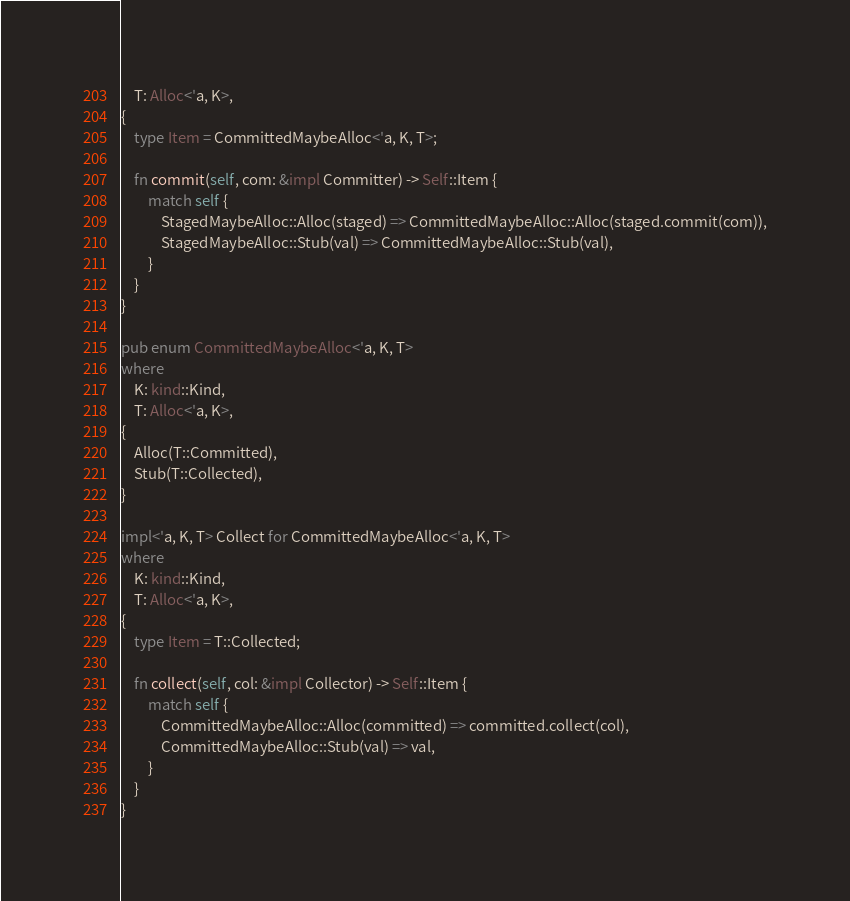<code> <loc_0><loc_0><loc_500><loc_500><_Rust_>    T: Alloc<'a, K>,
{
    type Item = CommittedMaybeAlloc<'a, K, T>;

    fn commit(self, com: &impl Committer) -> Self::Item {
        match self {
            StagedMaybeAlloc::Alloc(staged) => CommittedMaybeAlloc::Alloc(staged.commit(com)),
            StagedMaybeAlloc::Stub(val) => CommittedMaybeAlloc::Stub(val),
        }
    }
}

pub enum CommittedMaybeAlloc<'a, K, T>
where
    K: kind::Kind,
    T: Alloc<'a, K>,
{
    Alloc(T::Committed),
    Stub(T::Collected),
}

impl<'a, K, T> Collect for CommittedMaybeAlloc<'a, K, T>
where
    K: kind::Kind,
    T: Alloc<'a, K>,
{
    type Item = T::Collected;

    fn collect(self, col: &impl Collector) -> Self::Item {
        match self {
            CommittedMaybeAlloc::Alloc(committed) => committed.collect(col),
            CommittedMaybeAlloc::Stub(val) => val,
        }
    }
}
</code> 